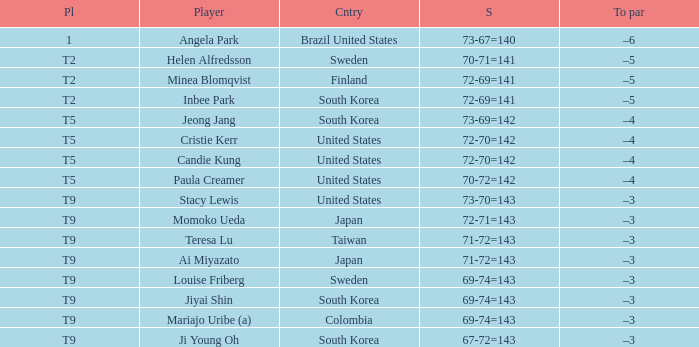What did Taiwan score? 71-72=143. 